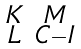<formula> <loc_0><loc_0><loc_500><loc_500>\begin{smallmatrix} K & M \\ L & C - I \end{smallmatrix}</formula> 